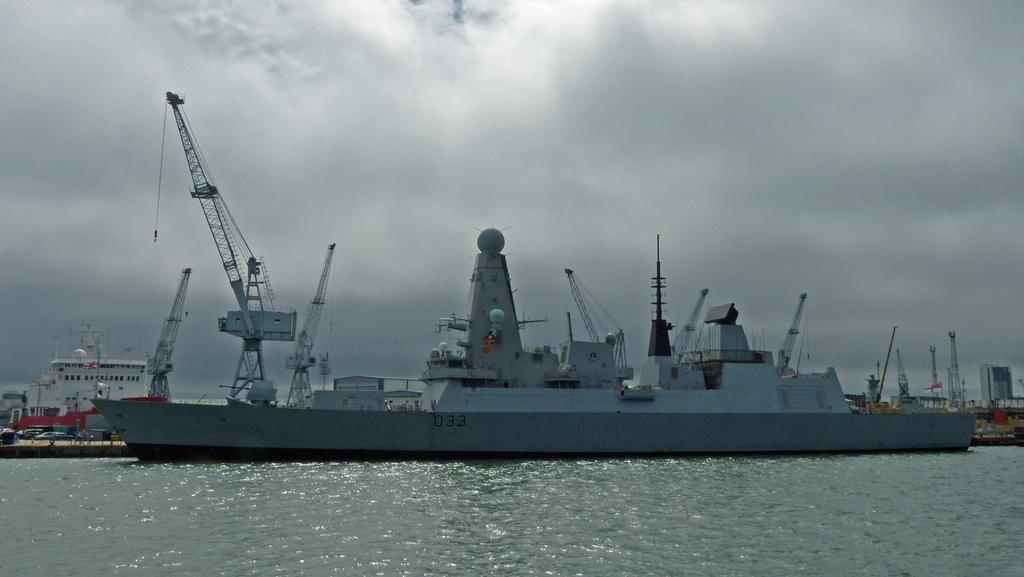What is the main subject of the image? The main subject of the image is ships. Where are the ships located? The ships are on water. What else can be seen in the background of the image? The sky is visible in the background of the image. How many tramps are visible on the ships in the image? There are no tramps present in the image; it features ships on water with a visible sky in the background. 